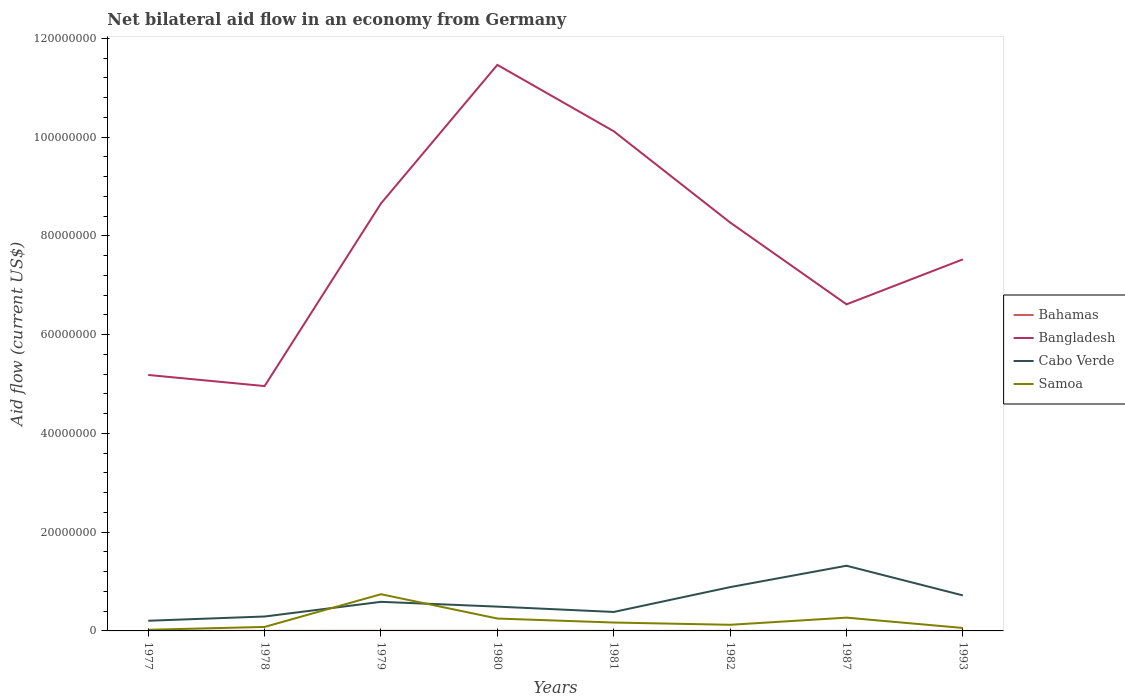Does the line corresponding to Bangladesh intersect with the line corresponding to Cabo Verde?
Your response must be concise. No. Is the number of lines equal to the number of legend labels?
Offer a terse response. Yes. In which year was the net bilateral aid flow in Cabo Verde maximum?
Make the answer very short. 1977. What is the total net bilateral aid flow in Bahamas in the graph?
Give a very brief answer. 10000. What is the difference between the highest and the second highest net bilateral aid flow in Cabo Verde?
Your answer should be compact. 1.11e+07. How many lines are there?
Ensure brevity in your answer.  4. Are the values on the major ticks of Y-axis written in scientific E-notation?
Your answer should be compact. No. Does the graph contain grids?
Your answer should be compact. No. What is the title of the graph?
Offer a terse response. Net bilateral aid flow in an economy from Germany. Does "Panama" appear as one of the legend labels in the graph?
Offer a very short reply. No. What is the Aid flow (current US$) of Bangladesh in 1977?
Keep it short and to the point. 5.18e+07. What is the Aid flow (current US$) of Cabo Verde in 1977?
Make the answer very short. 2.06e+06. What is the Aid flow (current US$) of Bahamas in 1978?
Ensure brevity in your answer.  10000. What is the Aid flow (current US$) of Bangladesh in 1978?
Your response must be concise. 4.96e+07. What is the Aid flow (current US$) of Cabo Verde in 1978?
Keep it short and to the point. 2.92e+06. What is the Aid flow (current US$) of Samoa in 1978?
Provide a short and direct response. 8.10e+05. What is the Aid flow (current US$) of Bangladesh in 1979?
Provide a short and direct response. 8.66e+07. What is the Aid flow (current US$) in Cabo Verde in 1979?
Offer a terse response. 5.89e+06. What is the Aid flow (current US$) in Samoa in 1979?
Offer a terse response. 7.43e+06. What is the Aid flow (current US$) of Bahamas in 1980?
Provide a short and direct response. 2.00e+04. What is the Aid flow (current US$) in Bangladesh in 1980?
Make the answer very short. 1.15e+08. What is the Aid flow (current US$) of Cabo Verde in 1980?
Provide a short and direct response. 4.92e+06. What is the Aid flow (current US$) in Samoa in 1980?
Offer a terse response. 2.51e+06. What is the Aid flow (current US$) of Bahamas in 1981?
Make the answer very short. 10000. What is the Aid flow (current US$) of Bangladesh in 1981?
Ensure brevity in your answer.  1.01e+08. What is the Aid flow (current US$) of Cabo Verde in 1981?
Keep it short and to the point. 3.84e+06. What is the Aid flow (current US$) of Samoa in 1981?
Your answer should be compact. 1.70e+06. What is the Aid flow (current US$) of Bangladesh in 1982?
Provide a short and direct response. 8.27e+07. What is the Aid flow (current US$) in Cabo Verde in 1982?
Offer a very short reply. 8.87e+06. What is the Aid flow (current US$) of Samoa in 1982?
Provide a succinct answer. 1.24e+06. What is the Aid flow (current US$) of Bahamas in 1987?
Your answer should be compact. 10000. What is the Aid flow (current US$) in Bangladesh in 1987?
Ensure brevity in your answer.  6.61e+07. What is the Aid flow (current US$) of Cabo Verde in 1987?
Your answer should be very brief. 1.32e+07. What is the Aid flow (current US$) in Samoa in 1987?
Ensure brevity in your answer.  2.69e+06. What is the Aid flow (current US$) in Bangladesh in 1993?
Make the answer very short. 7.52e+07. What is the Aid flow (current US$) in Cabo Verde in 1993?
Keep it short and to the point. 7.19e+06. Across all years, what is the maximum Aid flow (current US$) in Bahamas?
Your answer should be very brief. 2.00e+04. Across all years, what is the maximum Aid flow (current US$) in Bangladesh?
Give a very brief answer. 1.15e+08. Across all years, what is the maximum Aid flow (current US$) in Cabo Verde?
Offer a very short reply. 1.32e+07. Across all years, what is the maximum Aid flow (current US$) in Samoa?
Your response must be concise. 7.43e+06. Across all years, what is the minimum Aid flow (current US$) in Bangladesh?
Your answer should be very brief. 4.96e+07. Across all years, what is the minimum Aid flow (current US$) in Cabo Verde?
Provide a succinct answer. 2.06e+06. Across all years, what is the minimum Aid flow (current US$) of Samoa?
Offer a very short reply. 2.30e+05. What is the total Aid flow (current US$) of Bahamas in the graph?
Ensure brevity in your answer.  1.10e+05. What is the total Aid flow (current US$) of Bangladesh in the graph?
Keep it short and to the point. 6.28e+08. What is the total Aid flow (current US$) in Cabo Verde in the graph?
Make the answer very short. 4.89e+07. What is the total Aid flow (current US$) in Samoa in the graph?
Provide a succinct answer. 1.72e+07. What is the difference between the Aid flow (current US$) of Bangladesh in 1977 and that in 1978?
Your answer should be very brief. 2.25e+06. What is the difference between the Aid flow (current US$) of Cabo Verde in 1977 and that in 1978?
Your response must be concise. -8.60e+05. What is the difference between the Aid flow (current US$) of Samoa in 1977 and that in 1978?
Your answer should be compact. -5.80e+05. What is the difference between the Aid flow (current US$) of Bahamas in 1977 and that in 1979?
Make the answer very short. 0. What is the difference between the Aid flow (current US$) in Bangladesh in 1977 and that in 1979?
Offer a terse response. -3.47e+07. What is the difference between the Aid flow (current US$) of Cabo Verde in 1977 and that in 1979?
Offer a very short reply. -3.83e+06. What is the difference between the Aid flow (current US$) in Samoa in 1977 and that in 1979?
Give a very brief answer. -7.20e+06. What is the difference between the Aid flow (current US$) in Bangladesh in 1977 and that in 1980?
Ensure brevity in your answer.  -6.28e+07. What is the difference between the Aid flow (current US$) of Cabo Verde in 1977 and that in 1980?
Your answer should be very brief. -2.86e+06. What is the difference between the Aid flow (current US$) in Samoa in 1977 and that in 1980?
Ensure brevity in your answer.  -2.28e+06. What is the difference between the Aid flow (current US$) of Bahamas in 1977 and that in 1981?
Keep it short and to the point. 10000. What is the difference between the Aid flow (current US$) in Bangladesh in 1977 and that in 1981?
Your response must be concise. -4.94e+07. What is the difference between the Aid flow (current US$) of Cabo Verde in 1977 and that in 1981?
Keep it short and to the point. -1.78e+06. What is the difference between the Aid flow (current US$) in Samoa in 1977 and that in 1981?
Provide a succinct answer. -1.47e+06. What is the difference between the Aid flow (current US$) of Bangladesh in 1977 and that in 1982?
Provide a short and direct response. -3.09e+07. What is the difference between the Aid flow (current US$) in Cabo Verde in 1977 and that in 1982?
Make the answer very short. -6.81e+06. What is the difference between the Aid flow (current US$) of Samoa in 1977 and that in 1982?
Your answer should be very brief. -1.01e+06. What is the difference between the Aid flow (current US$) of Bangladesh in 1977 and that in 1987?
Ensure brevity in your answer.  -1.43e+07. What is the difference between the Aid flow (current US$) of Cabo Verde in 1977 and that in 1987?
Offer a terse response. -1.11e+07. What is the difference between the Aid flow (current US$) of Samoa in 1977 and that in 1987?
Give a very brief answer. -2.46e+06. What is the difference between the Aid flow (current US$) of Bahamas in 1977 and that in 1993?
Provide a short and direct response. 10000. What is the difference between the Aid flow (current US$) of Bangladesh in 1977 and that in 1993?
Your answer should be very brief. -2.34e+07. What is the difference between the Aid flow (current US$) in Cabo Verde in 1977 and that in 1993?
Give a very brief answer. -5.13e+06. What is the difference between the Aid flow (current US$) of Samoa in 1977 and that in 1993?
Make the answer very short. -3.70e+05. What is the difference between the Aid flow (current US$) of Bangladesh in 1978 and that in 1979?
Keep it short and to the point. -3.70e+07. What is the difference between the Aid flow (current US$) of Cabo Verde in 1978 and that in 1979?
Give a very brief answer. -2.97e+06. What is the difference between the Aid flow (current US$) of Samoa in 1978 and that in 1979?
Your response must be concise. -6.62e+06. What is the difference between the Aid flow (current US$) of Bahamas in 1978 and that in 1980?
Offer a very short reply. -10000. What is the difference between the Aid flow (current US$) in Bangladesh in 1978 and that in 1980?
Your response must be concise. -6.50e+07. What is the difference between the Aid flow (current US$) of Cabo Verde in 1978 and that in 1980?
Provide a short and direct response. -2.00e+06. What is the difference between the Aid flow (current US$) in Samoa in 1978 and that in 1980?
Provide a succinct answer. -1.70e+06. What is the difference between the Aid flow (current US$) of Bahamas in 1978 and that in 1981?
Keep it short and to the point. 0. What is the difference between the Aid flow (current US$) in Bangladesh in 1978 and that in 1981?
Give a very brief answer. -5.16e+07. What is the difference between the Aid flow (current US$) of Cabo Verde in 1978 and that in 1981?
Ensure brevity in your answer.  -9.20e+05. What is the difference between the Aid flow (current US$) in Samoa in 1978 and that in 1981?
Offer a terse response. -8.90e+05. What is the difference between the Aid flow (current US$) in Bangladesh in 1978 and that in 1982?
Give a very brief answer. -3.31e+07. What is the difference between the Aid flow (current US$) of Cabo Verde in 1978 and that in 1982?
Provide a short and direct response. -5.95e+06. What is the difference between the Aid flow (current US$) in Samoa in 1978 and that in 1982?
Give a very brief answer. -4.30e+05. What is the difference between the Aid flow (current US$) in Bangladesh in 1978 and that in 1987?
Give a very brief answer. -1.66e+07. What is the difference between the Aid flow (current US$) in Cabo Verde in 1978 and that in 1987?
Offer a very short reply. -1.03e+07. What is the difference between the Aid flow (current US$) in Samoa in 1978 and that in 1987?
Give a very brief answer. -1.88e+06. What is the difference between the Aid flow (current US$) in Bahamas in 1978 and that in 1993?
Ensure brevity in your answer.  0. What is the difference between the Aid flow (current US$) in Bangladesh in 1978 and that in 1993?
Offer a terse response. -2.57e+07. What is the difference between the Aid flow (current US$) in Cabo Verde in 1978 and that in 1993?
Give a very brief answer. -4.27e+06. What is the difference between the Aid flow (current US$) of Bangladesh in 1979 and that in 1980?
Give a very brief answer. -2.81e+07. What is the difference between the Aid flow (current US$) in Cabo Verde in 1979 and that in 1980?
Your answer should be compact. 9.70e+05. What is the difference between the Aid flow (current US$) of Samoa in 1979 and that in 1980?
Keep it short and to the point. 4.92e+06. What is the difference between the Aid flow (current US$) in Bahamas in 1979 and that in 1981?
Give a very brief answer. 10000. What is the difference between the Aid flow (current US$) in Bangladesh in 1979 and that in 1981?
Your answer should be very brief. -1.46e+07. What is the difference between the Aid flow (current US$) of Cabo Verde in 1979 and that in 1981?
Your answer should be compact. 2.05e+06. What is the difference between the Aid flow (current US$) in Samoa in 1979 and that in 1981?
Your response must be concise. 5.73e+06. What is the difference between the Aid flow (current US$) of Bangladesh in 1979 and that in 1982?
Make the answer very short. 3.85e+06. What is the difference between the Aid flow (current US$) of Cabo Verde in 1979 and that in 1982?
Your response must be concise. -2.98e+06. What is the difference between the Aid flow (current US$) of Samoa in 1979 and that in 1982?
Give a very brief answer. 6.19e+06. What is the difference between the Aid flow (current US$) in Bangladesh in 1979 and that in 1987?
Your answer should be compact. 2.04e+07. What is the difference between the Aid flow (current US$) of Cabo Verde in 1979 and that in 1987?
Offer a terse response. -7.31e+06. What is the difference between the Aid flow (current US$) in Samoa in 1979 and that in 1987?
Your answer should be very brief. 4.74e+06. What is the difference between the Aid flow (current US$) in Bahamas in 1979 and that in 1993?
Offer a terse response. 10000. What is the difference between the Aid flow (current US$) in Bangladesh in 1979 and that in 1993?
Make the answer very short. 1.13e+07. What is the difference between the Aid flow (current US$) of Cabo Verde in 1979 and that in 1993?
Your answer should be compact. -1.30e+06. What is the difference between the Aid flow (current US$) of Samoa in 1979 and that in 1993?
Give a very brief answer. 6.83e+06. What is the difference between the Aid flow (current US$) in Bahamas in 1980 and that in 1981?
Give a very brief answer. 10000. What is the difference between the Aid flow (current US$) of Bangladesh in 1980 and that in 1981?
Make the answer very short. 1.34e+07. What is the difference between the Aid flow (current US$) of Cabo Verde in 1980 and that in 1981?
Offer a very short reply. 1.08e+06. What is the difference between the Aid flow (current US$) of Samoa in 1980 and that in 1981?
Give a very brief answer. 8.10e+05. What is the difference between the Aid flow (current US$) of Bahamas in 1980 and that in 1982?
Make the answer very short. 10000. What is the difference between the Aid flow (current US$) in Bangladesh in 1980 and that in 1982?
Give a very brief answer. 3.19e+07. What is the difference between the Aid flow (current US$) in Cabo Verde in 1980 and that in 1982?
Give a very brief answer. -3.95e+06. What is the difference between the Aid flow (current US$) of Samoa in 1980 and that in 1982?
Ensure brevity in your answer.  1.27e+06. What is the difference between the Aid flow (current US$) of Bahamas in 1980 and that in 1987?
Provide a succinct answer. 10000. What is the difference between the Aid flow (current US$) in Bangladesh in 1980 and that in 1987?
Provide a succinct answer. 4.85e+07. What is the difference between the Aid flow (current US$) in Cabo Verde in 1980 and that in 1987?
Make the answer very short. -8.28e+06. What is the difference between the Aid flow (current US$) of Samoa in 1980 and that in 1987?
Keep it short and to the point. -1.80e+05. What is the difference between the Aid flow (current US$) in Bangladesh in 1980 and that in 1993?
Your answer should be very brief. 3.94e+07. What is the difference between the Aid flow (current US$) of Cabo Verde in 1980 and that in 1993?
Ensure brevity in your answer.  -2.27e+06. What is the difference between the Aid flow (current US$) of Samoa in 1980 and that in 1993?
Offer a very short reply. 1.91e+06. What is the difference between the Aid flow (current US$) in Bahamas in 1981 and that in 1982?
Ensure brevity in your answer.  0. What is the difference between the Aid flow (current US$) in Bangladesh in 1981 and that in 1982?
Give a very brief answer. 1.85e+07. What is the difference between the Aid flow (current US$) of Cabo Verde in 1981 and that in 1982?
Your response must be concise. -5.03e+06. What is the difference between the Aid flow (current US$) in Samoa in 1981 and that in 1982?
Provide a succinct answer. 4.60e+05. What is the difference between the Aid flow (current US$) of Bangladesh in 1981 and that in 1987?
Offer a very short reply. 3.50e+07. What is the difference between the Aid flow (current US$) in Cabo Verde in 1981 and that in 1987?
Make the answer very short. -9.36e+06. What is the difference between the Aid flow (current US$) of Samoa in 1981 and that in 1987?
Keep it short and to the point. -9.90e+05. What is the difference between the Aid flow (current US$) of Bahamas in 1981 and that in 1993?
Keep it short and to the point. 0. What is the difference between the Aid flow (current US$) of Bangladesh in 1981 and that in 1993?
Offer a terse response. 2.59e+07. What is the difference between the Aid flow (current US$) in Cabo Verde in 1981 and that in 1993?
Offer a very short reply. -3.35e+06. What is the difference between the Aid flow (current US$) in Samoa in 1981 and that in 1993?
Offer a terse response. 1.10e+06. What is the difference between the Aid flow (current US$) in Bahamas in 1982 and that in 1987?
Keep it short and to the point. 0. What is the difference between the Aid flow (current US$) of Bangladesh in 1982 and that in 1987?
Offer a terse response. 1.66e+07. What is the difference between the Aid flow (current US$) in Cabo Verde in 1982 and that in 1987?
Make the answer very short. -4.33e+06. What is the difference between the Aid flow (current US$) in Samoa in 1982 and that in 1987?
Give a very brief answer. -1.45e+06. What is the difference between the Aid flow (current US$) of Bangladesh in 1982 and that in 1993?
Provide a succinct answer. 7.47e+06. What is the difference between the Aid flow (current US$) in Cabo Verde in 1982 and that in 1993?
Offer a terse response. 1.68e+06. What is the difference between the Aid flow (current US$) of Samoa in 1982 and that in 1993?
Offer a terse response. 6.40e+05. What is the difference between the Aid flow (current US$) of Bangladesh in 1987 and that in 1993?
Your answer should be very brief. -9.11e+06. What is the difference between the Aid flow (current US$) in Cabo Verde in 1987 and that in 1993?
Provide a succinct answer. 6.01e+06. What is the difference between the Aid flow (current US$) of Samoa in 1987 and that in 1993?
Your answer should be compact. 2.09e+06. What is the difference between the Aid flow (current US$) of Bahamas in 1977 and the Aid flow (current US$) of Bangladesh in 1978?
Keep it short and to the point. -4.96e+07. What is the difference between the Aid flow (current US$) of Bahamas in 1977 and the Aid flow (current US$) of Cabo Verde in 1978?
Make the answer very short. -2.90e+06. What is the difference between the Aid flow (current US$) in Bahamas in 1977 and the Aid flow (current US$) in Samoa in 1978?
Provide a succinct answer. -7.90e+05. What is the difference between the Aid flow (current US$) of Bangladesh in 1977 and the Aid flow (current US$) of Cabo Verde in 1978?
Your answer should be very brief. 4.89e+07. What is the difference between the Aid flow (current US$) in Bangladesh in 1977 and the Aid flow (current US$) in Samoa in 1978?
Provide a short and direct response. 5.10e+07. What is the difference between the Aid flow (current US$) in Cabo Verde in 1977 and the Aid flow (current US$) in Samoa in 1978?
Keep it short and to the point. 1.25e+06. What is the difference between the Aid flow (current US$) in Bahamas in 1977 and the Aid flow (current US$) in Bangladesh in 1979?
Provide a short and direct response. -8.65e+07. What is the difference between the Aid flow (current US$) in Bahamas in 1977 and the Aid flow (current US$) in Cabo Verde in 1979?
Make the answer very short. -5.87e+06. What is the difference between the Aid flow (current US$) of Bahamas in 1977 and the Aid flow (current US$) of Samoa in 1979?
Offer a terse response. -7.41e+06. What is the difference between the Aid flow (current US$) in Bangladesh in 1977 and the Aid flow (current US$) in Cabo Verde in 1979?
Provide a short and direct response. 4.59e+07. What is the difference between the Aid flow (current US$) in Bangladesh in 1977 and the Aid flow (current US$) in Samoa in 1979?
Keep it short and to the point. 4.44e+07. What is the difference between the Aid flow (current US$) of Cabo Verde in 1977 and the Aid flow (current US$) of Samoa in 1979?
Ensure brevity in your answer.  -5.37e+06. What is the difference between the Aid flow (current US$) in Bahamas in 1977 and the Aid flow (current US$) in Bangladesh in 1980?
Your response must be concise. -1.15e+08. What is the difference between the Aid flow (current US$) of Bahamas in 1977 and the Aid flow (current US$) of Cabo Verde in 1980?
Offer a terse response. -4.90e+06. What is the difference between the Aid flow (current US$) in Bahamas in 1977 and the Aid flow (current US$) in Samoa in 1980?
Your response must be concise. -2.49e+06. What is the difference between the Aid flow (current US$) of Bangladesh in 1977 and the Aid flow (current US$) of Cabo Verde in 1980?
Your answer should be very brief. 4.69e+07. What is the difference between the Aid flow (current US$) of Bangladesh in 1977 and the Aid flow (current US$) of Samoa in 1980?
Keep it short and to the point. 4.93e+07. What is the difference between the Aid flow (current US$) in Cabo Verde in 1977 and the Aid flow (current US$) in Samoa in 1980?
Provide a short and direct response. -4.50e+05. What is the difference between the Aid flow (current US$) in Bahamas in 1977 and the Aid flow (current US$) in Bangladesh in 1981?
Keep it short and to the point. -1.01e+08. What is the difference between the Aid flow (current US$) of Bahamas in 1977 and the Aid flow (current US$) of Cabo Verde in 1981?
Your answer should be very brief. -3.82e+06. What is the difference between the Aid flow (current US$) in Bahamas in 1977 and the Aid flow (current US$) in Samoa in 1981?
Offer a very short reply. -1.68e+06. What is the difference between the Aid flow (current US$) in Bangladesh in 1977 and the Aid flow (current US$) in Cabo Verde in 1981?
Ensure brevity in your answer.  4.80e+07. What is the difference between the Aid flow (current US$) of Bangladesh in 1977 and the Aid flow (current US$) of Samoa in 1981?
Your answer should be compact. 5.01e+07. What is the difference between the Aid flow (current US$) of Cabo Verde in 1977 and the Aid flow (current US$) of Samoa in 1981?
Keep it short and to the point. 3.60e+05. What is the difference between the Aid flow (current US$) in Bahamas in 1977 and the Aid flow (current US$) in Bangladesh in 1982?
Provide a succinct answer. -8.27e+07. What is the difference between the Aid flow (current US$) of Bahamas in 1977 and the Aid flow (current US$) of Cabo Verde in 1982?
Make the answer very short. -8.85e+06. What is the difference between the Aid flow (current US$) of Bahamas in 1977 and the Aid flow (current US$) of Samoa in 1982?
Give a very brief answer. -1.22e+06. What is the difference between the Aid flow (current US$) in Bangladesh in 1977 and the Aid flow (current US$) in Cabo Verde in 1982?
Make the answer very short. 4.30e+07. What is the difference between the Aid flow (current US$) of Bangladesh in 1977 and the Aid flow (current US$) of Samoa in 1982?
Give a very brief answer. 5.06e+07. What is the difference between the Aid flow (current US$) in Cabo Verde in 1977 and the Aid flow (current US$) in Samoa in 1982?
Make the answer very short. 8.20e+05. What is the difference between the Aid flow (current US$) of Bahamas in 1977 and the Aid flow (current US$) of Bangladesh in 1987?
Offer a terse response. -6.61e+07. What is the difference between the Aid flow (current US$) in Bahamas in 1977 and the Aid flow (current US$) in Cabo Verde in 1987?
Offer a very short reply. -1.32e+07. What is the difference between the Aid flow (current US$) in Bahamas in 1977 and the Aid flow (current US$) in Samoa in 1987?
Provide a short and direct response. -2.67e+06. What is the difference between the Aid flow (current US$) of Bangladesh in 1977 and the Aid flow (current US$) of Cabo Verde in 1987?
Ensure brevity in your answer.  3.86e+07. What is the difference between the Aid flow (current US$) in Bangladesh in 1977 and the Aid flow (current US$) in Samoa in 1987?
Give a very brief answer. 4.91e+07. What is the difference between the Aid flow (current US$) in Cabo Verde in 1977 and the Aid flow (current US$) in Samoa in 1987?
Keep it short and to the point. -6.30e+05. What is the difference between the Aid flow (current US$) in Bahamas in 1977 and the Aid flow (current US$) in Bangladesh in 1993?
Offer a terse response. -7.52e+07. What is the difference between the Aid flow (current US$) in Bahamas in 1977 and the Aid flow (current US$) in Cabo Verde in 1993?
Offer a terse response. -7.17e+06. What is the difference between the Aid flow (current US$) of Bahamas in 1977 and the Aid flow (current US$) of Samoa in 1993?
Offer a terse response. -5.80e+05. What is the difference between the Aid flow (current US$) of Bangladesh in 1977 and the Aid flow (current US$) of Cabo Verde in 1993?
Offer a terse response. 4.46e+07. What is the difference between the Aid flow (current US$) in Bangladesh in 1977 and the Aid flow (current US$) in Samoa in 1993?
Keep it short and to the point. 5.12e+07. What is the difference between the Aid flow (current US$) of Cabo Verde in 1977 and the Aid flow (current US$) of Samoa in 1993?
Your answer should be very brief. 1.46e+06. What is the difference between the Aid flow (current US$) of Bahamas in 1978 and the Aid flow (current US$) of Bangladesh in 1979?
Give a very brief answer. -8.66e+07. What is the difference between the Aid flow (current US$) in Bahamas in 1978 and the Aid flow (current US$) in Cabo Verde in 1979?
Provide a succinct answer. -5.88e+06. What is the difference between the Aid flow (current US$) of Bahamas in 1978 and the Aid flow (current US$) of Samoa in 1979?
Make the answer very short. -7.42e+06. What is the difference between the Aid flow (current US$) in Bangladesh in 1978 and the Aid flow (current US$) in Cabo Verde in 1979?
Provide a short and direct response. 4.37e+07. What is the difference between the Aid flow (current US$) of Bangladesh in 1978 and the Aid flow (current US$) of Samoa in 1979?
Offer a very short reply. 4.22e+07. What is the difference between the Aid flow (current US$) in Cabo Verde in 1978 and the Aid flow (current US$) in Samoa in 1979?
Provide a short and direct response. -4.51e+06. What is the difference between the Aid flow (current US$) of Bahamas in 1978 and the Aid flow (current US$) of Bangladesh in 1980?
Offer a terse response. -1.15e+08. What is the difference between the Aid flow (current US$) in Bahamas in 1978 and the Aid flow (current US$) in Cabo Verde in 1980?
Offer a very short reply. -4.91e+06. What is the difference between the Aid flow (current US$) in Bahamas in 1978 and the Aid flow (current US$) in Samoa in 1980?
Provide a short and direct response. -2.50e+06. What is the difference between the Aid flow (current US$) in Bangladesh in 1978 and the Aid flow (current US$) in Cabo Verde in 1980?
Keep it short and to the point. 4.47e+07. What is the difference between the Aid flow (current US$) of Bangladesh in 1978 and the Aid flow (current US$) of Samoa in 1980?
Your response must be concise. 4.71e+07. What is the difference between the Aid flow (current US$) of Bahamas in 1978 and the Aid flow (current US$) of Bangladesh in 1981?
Your answer should be very brief. -1.01e+08. What is the difference between the Aid flow (current US$) in Bahamas in 1978 and the Aid flow (current US$) in Cabo Verde in 1981?
Your answer should be compact. -3.83e+06. What is the difference between the Aid flow (current US$) in Bahamas in 1978 and the Aid flow (current US$) in Samoa in 1981?
Provide a succinct answer. -1.69e+06. What is the difference between the Aid flow (current US$) in Bangladesh in 1978 and the Aid flow (current US$) in Cabo Verde in 1981?
Keep it short and to the point. 4.57e+07. What is the difference between the Aid flow (current US$) of Bangladesh in 1978 and the Aid flow (current US$) of Samoa in 1981?
Keep it short and to the point. 4.79e+07. What is the difference between the Aid flow (current US$) of Cabo Verde in 1978 and the Aid flow (current US$) of Samoa in 1981?
Provide a short and direct response. 1.22e+06. What is the difference between the Aid flow (current US$) of Bahamas in 1978 and the Aid flow (current US$) of Bangladesh in 1982?
Offer a terse response. -8.27e+07. What is the difference between the Aid flow (current US$) in Bahamas in 1978 and the Aid flow (current US$) in Cabo Verde in 1982?
Keep it short and to the point. -8.86e+06. What is the difference between the Aid flow (current US$) in Bahamas in 1978 and the Aid flow (current US$) in Samoa in 1982?
Your response must be concise. -1.23e+06. What is the difference between the Aid flow (current US$) in Bangladesh in 1978 and the Aid flow (current US$) in Cabo Verde in 1982?
Ensure brevity in your answer.  4.07e+07. What is the difference between the Aid flow (current US$) of Bangladesh in 1978 and the Aid flow (current US$) of Samoa in 1982?
Keep it short and to the point. 4.83e+07. What is the difference between the Aid flow (current US$) in Cabo Verde in 1978 and the Aid flow (current US$) in Samoa in 1982?
Provide a succinct answer. 1.68e+06. What is the difference between the Aid flow (current US$) of Bahamas in 1978 and the Aid flow (current US$) of Bangladesh in 1987?
Offer a terse response. -6.61e+07. What is the difference between the Aid flow (current US$) of Bahamas in 1978 and the Aid flow (current US$) of Cabo Verde in 1987?
Ensure brevity in your answer.  -1.32e+07. What is the difference between the Aid flow (current US$) of Bahamas in 1978 and the Aid flow (current US$) of Samoa in 1987?
Offer a very short reply. -2.68e+06. What is the difference between the Aid flow (current US$) of Bangladesh in 1978 and the Aid flow (current US$) of Cabo Verde in 1987?
Offer a very short reply. 3.64e+07. What is the difference between the Aid flow (current US$) of Bangladesh in 1978 and the Aid flow (current US$) of Samoa in 1987?
Your response must be concise. 4.69e+07. What is the difference between the Aid flow (current US$) of Bahamas in 1978 and the Aid flow (current US$) of Bangladesh in 1993?
Your answer should be very brief. -7.52e+07. What is the difference between the Aid flow (current US$) in Bahamas in 1978 and the Aid flow (current US$) in Cabo Verde in 1993?
Your answer should be compact. -7.18e+06. What is the difference between the Aid flow (current US$) in Bahamas in 1978 and the Aid flow (current US$) in Samoa in 1993?
Your answer should be compact. -5.90e+05. What is the difference between the Aid flow (current US$) of Bangladesh in 1978 and the Aid flow (current US$) of Cabo Verde in 1993?
Your answer should be very brief. 4.24e+07. What is the difference between the Aid flow (current US$) in Bangladesh in 1978 and the Aid flow (current US$) in Samoa in 1993?
Make the answer very short. 4.90e+07. What is the difference between the Aid flow (current US$) of Cabo Verde in 1978 and the Aid flow (current US$) of Samoa in 1993?
Your answer should be compact. 2.32e+06. What is the difference between the Aid flow (current US$) of Bahamas in 1979 and the Aid flow (current US$) of Bangladesh in 1980?
Your answer should be very brief. -1.15e+08. What is the difference between the Aid flow (current US$) of Bahamas in 1979 and the Aid flow (current US$) of Cabo Verde in 1980?
Your answer should be very brief. -4.90e+06. What is the difference between the Aid flow (current US$) in Bahamas in 1979 and the Aid flow (current US$) in Samoa in 1980?
Offer a very short reply. -2.49e+06. What is the difference between the Aid flow (current US$) of Bangladesh in 1979 and the Aid flow (current US$) of Cabo Verde in 1980?
Make the answer very short. 8.16e+07. What is the difference between the Aid flow (current US$) in Bangladesh in 1979 and the Aid flow (current US$) in Samoa in 1980?
Your response must be concise. 8.40e+07. What is the difference between the Aid flow (current US$) in Cabo Verde in 1979 and the Aid flow (current US$) in Samoa in 1980?
Your response must be concise. 3.38e+06. What is the difference between the Aid flow (current US$) of Bahamas in 1979 and the Aid flow (current US$) of Bangladesh in 1981?
Make the answer very short. -1.01e+08. What is the difference between the Aid flow (current US$) of Bahamas in 1979 and the Aid flow (current US$) of Cabo Verde in 1981?
Your response must be concise. -3.82e+06. What is the difference between the Aid flow (current US$) of Bahamas in 1979 and the Aid flow (current US$) of Samoa in 1981?
Offer a terse response. -1.68e+06. What is the difference between the Aid flow (current US$) of Bangladesh in 1979 and the Aid flow (current US$) of Cabo Verde in 1981?
Make the answer very short. 8.27e+07. What is the difference between the Aid flow (current US$) in Bangladesh in 1979 and the Aid flow (current US$) in Samoa in 1981?
Keep it short and to the point. 8.49e+07. What is the difference between the Aid flow (current US$) of Cabo Verde in 1979 and the Aid flow (current US$) of Samoa in 1981?
Offer a very short reply. 4.19e+06. What is the difference between the Aid flow (current US$) of Bahamas in 1979 and the Aid flow (current US$) of Bangladesh in 1982?
Keep it short and to the point. -8.27e+07. What is the difference between the Aid flow (current US$) of Bahamas in 1979 and the Aid flow (current US$) of Cabo Verde in 1982?
Make the answer very short. -8.85e+06. What is the difference between the Aid flow (current US$) of Bahamas in 1979 and the Aid flow (current US$) of Samoa in 1982?
Give a very brief answer. -1.22e+06. What is the difference between the Aid flow (current US$) of Bangladesh in 1979 and the Aid flow (current US$) of Cabo Verde in 1982?
Offer a very short reply. 7.77e+07. What is the difference between the Aid flow (current US$) in Bangladesh in 1979 and the Aid flow (current US$) in Samoa in 1982?
Give a very brief answer. 8.53e+07. What is the difference between the Aid flow (current US$) of Cabo Verde in 1979 and the Aid flow (current US$) of Samoa in 1982?
Your response must be concise. 4.65e+06. What is the difference between the Aid flow (current US$) in Bahamas in 1979 and the Aid flow (current US$) in Bangladesh in 1987?
Give a very brief answer. -6.61e+07. What is the difference between the Aid flow (current US$) in Bahamas in 1979 and the Aid flow (current US$) in Cabo Verde in 1987?
Offer a terse response. -1.32e+07. What is the difference between the Aid flow (current US$) of Bahamas in 1979 and the Aid flow (current US$) of Samoa in 1987?
Make the answer very short. -2.67e+06. What is the difference between the Aid flow (current US$) in Bangladesh in 1979 and the Aid flow (current US$) in Cabo Verde in 1987?
Offer a very short reply. 7.34e+07. What is the difference between the Aid flow (current US$) of Bangladesh in 1979 and the Aid flow (current US$) of Samoa in 1987?
Offer a terse response. 8.39e+07. What is the difference between the Aid flow (current US$) in Cabo Verde in 1979 and the Aid flow (current US$) in Samoa in 1987?
Offer a terse response. 3.20e+06. What is the difference between the Aid flow (current US$) of Bahamas in 1979 and the Aid flow (current US$) of Bangladesh in 1993?
Make the answer very short. -7.52e+07. What is the difference between the Aid flow (current US$) in Bahamas in 1979 and the Aid flow (current US$) in Cabo Verde in 1993?
Provide a succinct answer. -7.17e+06. What is the difference between the Aid flow (current US$) in Bahamas in 1979 and the Aid flow (current US$) in Samoa in 1993?
Offer a very short reply. -5.80e+05. What is the difference between the Aid flow (current US$) of Bangladesh in 1979 and the Aid flow (current US$) of Cabo Verde in 1993?
Ensure brevity in your answer.  7.94e+07. What is the difference between the Aid flow (current US$) of Bangladesh in 1979 and the Aid flow (current US$) of Samoa in 1993?
Make the answer very short. 8.60e+07. What is the difference between the Aid flow (current US$) of Cabo Verde in 1979 and the Aid flow (current US$) of Samoa in 1993?
Provide a short and direct response. 5.29e+06. What is the difference between the Aid flow (current US$) in Bahamas in 1980 and the Aid flow (current US$) in Bangladesh in 1981?
Provide a short and direct response. -1.01e+08. What is the difference between the Aid flow (current US$) in Bahamas in 1980 and the Aid flow (current US$) in Cabo Verde in 1981?
Make the answer very short. -3.82e+06. What is the difference between the Aid flow (current US$) of Bahamas in 1980 and the Aid flow (current US$) of Samoa in 1981?
Give a very brief answer. -1.68e+06. What is the difference between the Aid flow (current US$) in Bangladesh in 1980 and the Aid flow (current US$) in Cabo Verde in 1981?
Make the answer very short. 1.11e+08. What is the difference between the Aid flow (current US$) of Bangladesh in 1980 and the Aid flow (current US$) of Samoa in 1981?
Make the answer very short. 1.13e+08. What is the difference between the Aid flow (current US$) in Cabo Verde in 1980 and the Aid flow (current US$) in Samoa in 1981?
Provide a short and direct response. 3.22e+06. What is the difference between the Aid flow (current US$) of Bahamas in 1980 and the Aid flow (current US$) of Bangladesh in 1982?
Offer a terse response. -8.27e+07. What is the difference between the Aid flow (current US$) in Bahamas in 1980 and the Aid flow (current US$) in Cabo Verde in 1982?
Ensure brevity in your answer.  -8.85e+06. What is the difference between the Aid flow (current US$) of Bahamas in 1980 and the Aid flow (current US$) of Samoa in 1982?
Ensure brevity in your answer.  -1.22e+06. What is the difference between the Aid flow (current US$) in Bangladesh in 1980 and the Aid flow (current US$) in Cabo Verde in 1982?
Keep it short and to the point. 1.06e+08. What is the difference between the Aid flow (current US$) of Bangladesh in 1980 and the Aid flow (current US$) of Samoa in 1982?
Keep it short and to the point. 1.13e+08. What is the difference between the Aid flow (current US$) of Cabo Verde in 1980 and the Aid flow (current US$) of Samoa in 1982?
Make the answer very short. 3.68e+06. What is the difference between the Aid flow (current US$) in Bahamas in 1980 and the Aid flow (current US$) in Bangladesh in 1987?
Keep it short and to the point. -6.61e+07. What is the difference between the Aid flow (current US$) of Bahamas in 1980 and the Aid flow (current US$) of Cabo Verde in 1987?
Offer a terse response. -1.32e+07. What is the difference between the Aid flow (current US$) of Bahamas in 1980 and the Aid flow (current US$) of Samoa in 1987?
Make the answer very short. -2.67e+06. What is the difference between the Aid flow (current US$) of Bangladesh in 1980 and the Aid flow (current US$) of Cabo Verde in 1987?
Provide a succinct answer. 1.01e+08. What is the difference between the Aid flow (current US$) in Bangladesh in 1980 and the Aid flow (current US$) in Samoa in 1987?
Offer a terse response. 1.12e+08. What is the difference between the Aid flow (current US$) of Cabo Verde in 1980 and the Aid flow (current US$) of Samoa in 1987?
Your response must be concise. 2.23e+06. What is the difference between the Aid flow (current US$) in Bahamas in 1980 and the Aid flow (current US$) in Bangladesh in 1993?
Keep it short and to the point. -7.52e+07. What is the difference between the Aid flow (current US$) in Bahamas in 1980 and the Aid flow (current US$) in Cabo Verde in 1993?
Your answer should be compact. -7.17e+06. What is the difference between the Aid flow (current US$) in Bahamas in 1980 and the Aid flow (current US$) in Samoa in 1993?
Your response must be concise. -5.80e+05. What is the difference between the Aid flow (current US$) of Bangladesh in 1980 and the Aid flow (current US$) of Cabo Verde in 1993?
Provide a short and direct response. 1.07e+08. What is the difference between the Aid flow (current US$) in Bangladesh in 1980 and the Aid flow (current US$) in Samoa in 1993?
Give a very brief answer. 1.14e+08. What is the difference between the Aid flow (current US$) of Cabo Verde in 1980 and the Aid flow (current US$) of Samoa in 1993?
Provide a short and direct response. 4.32e+06. What is the difference between the Aid flow (current US$) in Bahamas in 1981 and the Aid flow (current US$) in Bangladesh in 1982?
Make the answer very short. -8.27e+07. What is the difference between the Aid flow (current US$) of Bahamas in 1981 and the Aid flow (current US$) of Cabo Verde in 1982?
Make the answer very short. -8.86e+06. What is the difference between the Aid flow (current US$) in Bahamas in 1981 and the Aid flow (current US$) in Samoa in 1982?
Provide a succinct answer. -1.23e+06. What is the difference between the Aid flow (current US$) in Bangladesh in 1981 and the Aid flow (current US$) in Cabo Verde in 1982?
Your answer should be compact. 9.23e+07. What is the difference between the Aid flow (current US$) of Bangladesh in 1981 and the Aid flow (current US$) of Samoa in 1982?
Give a very brief answer. 9.99e+07. What is the difference between the Aid flow (current US$) of Cabo Verde in 1981 and the Aid flow (current US$) of Samoa in 1982?
Keep it short and to the point. 2.60e+06. What is the difference between the Aid flow (current US$) in Bahamas in 1981 and the Aid flow (current US$) in Bangladesh in 1987?
Keep it short and to the point. -6.61e+07. What is the difference between the Aid flow (current US$) of Bahamas in 1981 and the Aid flow (current US$) of Cabo Verde in 1987?
Your answer should be compact. -1.32e+07. What is the difference between the Aid flow (current US$) in Bahamas in 1981 and the Aid flow (current US$) in Samoa in 1987?
Your response must be concise. -2.68e+06. What is the difference between the Aid flow (current US$) in Bangladesh in 1981 and the Aid flow (current US$) in Cabo Verde in 1987?
Provide a short and direct response. 8.80e+07. What is the difference between the Aid flow (current US$) of Bangladesh in 1981 and the Aid flow (current US$) of Samoa in 1987?
Make the answer very short. 9.85e+07. What is the difference between the Aid flow (current US$) in Cabo Verde in 1981 and the Aid flow (current US$) in Samoa in 1987?
Offer a terse response. 1.15e+06. What is the difference between the Aid flow (current US$) of Bahamas in 1981 and the Aid flow (current US$) of Bangladesh in 1993?
Your answer should be very brief. -7.52e+07. What is the difference between the Aid flow (current US$) in Bahamas in 1981 and the Aid flow (current US$) in Cabo Verde in 1993?
Make the answer very short. -7.18e+06. What is the difference between the Aid flow (current US$) in Bahamas in 1981 and the Aid flow (current US$) in Samoa in 1993?
Offer a terse response. -5.90e+05. What is the difference between the Aid flow (current US$) of Bangladesh in 1981 and the Aid flow (current US$) of Cabo Verde in 1993?
Your answer should be very brief. 9.40e+07. What is the difference between the Aid flow (current US$) in Bangladesh in 1981 and the Aid flow (current US$) in Samoa in 1993?
Offer a terse response. 1.01e+08. What is the difference between the Aid flow (current US$) in Cabo Verde in 1981 and the Aid flow (current US$) in Samoa in 1993?
Offer a terse response. 3.24e+06. What is the difference between the Aid flow (current US$) of Bahamas in 1982 and the Aid flow (current US$) of Bangladesh in 1987?
Offer a terse response. -6.61e+07. What is the difference between the Aid flow (current US$) of Bahamas in 1982 and the Aid flow (current US$) of Cabo Verde in 1987?
Provide a short and direct response. -1.32e+07. What is the difference between the Aid flow (current US$) in Bahamas in 1982 and the Aid flow (current US$) in Samoa in 1987?
Your answer should be compact. -2.68e+06. What is the difference between the Aid flow (current US$) of Bangladesh in 1982 and the Aid flow (current US$) of Cabo Verde in 1987?
Give a very brief answer. 6.95e+07. What is the difference between the Aid flow (current US$) in Bangladesh in 1982 and the Aid flow (current US$) in Samoa in 1987?
Offer a terse response. 8.00e+07. What is the difference between the Aid flow (current US$) in Cabo Verde in 1982 and the Aid flow (current US$) in Samoa in 1987?
Give a very brief answer. 6.18e+06. What is the difference between the Aid flow (current US$) in Bahamas in 1982 and the Aid flow (current US$) in Bangladesh in 1993?
Make the answer very short. -7.52e+07. What is the difference between the Aid flow (current US$) of Bahamas in 1982 and the Aid flow (current US$) of Cabo Verde in 1993?
Keep it short and to the point. -7.18e+06. What is the difference between the Aid flow (current US$) in Bahamas in 1982 and the Aid flow (current US$) in Samoa in 1993?
Give a very brief answer. -5.90e+05. What is the difference between the Aid flow (current US$) of Bangladesh in 1982 and the Aid flow (current US$) of Cabo Verde in 1993?
Provide a short and direct response. 7.55e+07. What is the difference between the Aid flow (current US$) of Bangladesh in 1982 and the Aid flow (current US$) of Samoa in 1993?
Give a very brief answer. 8.21e+07. What is the difference between the Aid flow (current US$) of Cabo Verde in 1982 and the Aid flow (current US$) of Samoa in 1993?
Provide a succinct answer. 8.27e+06. What is the difference between the Aid flow (current US$) in Bahamas in 1987 and the Aid flow (current US$) in Bangladesh in 1993?
Ensure brevity in your answer.  -7.52e+07. What is the difference between the Aid flow (current US$) in Bahamas in 1987 and the Aid flow (current US$) in Cabo Verde in 1993?
Give a very brief answer. -7.18e+06. What is the difference between the Aid flow (current US$) in Bahamas in 1987 and the Aid flow (current US$) in Samoa in 1993?
Make the answer very short. -5.90e+05. What is the difference between the Aid flow (current US$) of Bangladesh in 1987 and the Aid flow (current US$) of Cabo Verde in 1993?
Keep it short and to the point. 5.89e+07. What is the difference between the Aid flow (current US$) in Bangladesh in 1987 and the Aid flow (current US$) in Samoa in 1993?
Keep it short and to the point. 6.55e+07. What is the difference between the Aid flow (current US$) in Cabo Verde in 1987 and the Aid flow (current US$) in Samoa in 1993?
Provide a succinct answer. 1.26e+07. What is the average Aid flow (current US$) of Bahamas per year?
Keep it short and to the point. 1.38e+04. What is the average Aid flow (current US$) of Bangladesh per year?
Keep it short and to the point. 7.85e+07. What is the average Aid flow (current US$) in Cabo Verde per year?
Keep it short and to the point. 6.11e+06. What is the average Aid flow (current US$) of Samoa per year?
Give a very brief answer. 2.15e+06. In the year 1977, what is the difference between the Aid flow (current US$) of Bahamas and Aid flow (current US$) of Bangladesh?
Keep it short and to the point. -5.18e+07. In the year 1977, what is the difference between the Aid flow (current US$) in Bahamas and Aid flow (current US$) in Cabo Verde?
Your answer should be very brief. -2.04e+06. In the year 1977, what is the difference between the Aid flow (current US$) of Bangladesh and Aid flow (current US$) of Cabo Verde?
Your answer should be compact. 4.98e+07. In the year 1977, what is the difference between the Aid flow (current US$) of Bangladesh and Aid flow (current US$) of Samoa?
Give a very brief answer. 5.16e+07. In the year 1977, what is the difference between the Aid flow (current US$) of Cabo Verde and Aid flow (current US$) of Samoa?
Your answer should be compact. 1.83e+06. In the year 1978, what is the difference between the Aid flow (current US$) of Bahamas and Aid flow (current US$) of Bangladesh?
Your response must be concise. -4.96e+07. In the year 1978, what is the difference between the Aid flow (current US$) in Bahamas and Aid flow (current US$) in Cabo Verde?
Give a very brief answer. -2.91e+06. In the year 1978, what is the difference between the Aid flow (current US$) of Bahamas and Aid flow (current US$) of Samoa?
Your answer should be compact. -8.00e+05. In the year 1978, what is the difference between the Aid flow (current US$) of Bangladesh and Aid flow (current US$) of Cabo Verde?
Give a very brief answer. 4.67e+07. In the year 1978, what is the difference between the Aid flow (current US$) in Bangladesh and Aid flow (current US$) in Samoa?
Give a very brief answer. 4.88e+07. In the year 1978, what is the difference between the Aid flow (current US$) in Cabo Verde and Aid flow (current US$) in Samoa?
Provide a short and direct response. 2.11e+06. In the year 1979, what is the difference between the Aid flow (current US$) in Bahamas and Aid flow (current US$) in Bangladesh?
Keep it short and to the point. -8.65e+07. In the year 1979, what is the difference between the Aid flow (current US$) of Bahamas and Aid flow (current US$) of Cabo Verde?
Keep it short and to the point. -5.87e+06. In the year 1979, what is the difference between the Aid flow (current US$) in Bahamas and Aid flow (current US$) in Samoa?
Offer a very short reply. -7.41e+06. In the year 1979, what is the difference between the Aid flow (current US$) of Bangladesh and Aid flow (current US$) of Cabo Verde?
Your response must be concise. 8.07e+07. In the year 1979, what is the difference between the Aid flow (current US$) of Bangladesh and Aid flow (current US$) of Samoa?
Give a very brief answer. 7.91e+07. In the year 1979, what is the difference between the Aid flow (current US$) of Cabo Verde and Aid flow (current US$) of Samoa?
Offer a very short reply. -1.54e+06. In the year 1980, what is the difference between the Aid flow (current US$) of Bahamas and Aid flow (current US$) of Bangladesh?
Make the answer very short. -1.15e+08. In the year 1980, what is the difference between the Aid flow (current US$) in Bahamas and Aid flow (current US$) in Cabo Verde?
Make the answer very short. -4.90e+06. In the year 1980, what is the difference between the Aid flow (current US$) of Bahamas and Aid flow (current US$) of Samoa?
Keep it short and to the point. -2.49e+06. In the year 1980, what is the difference between the Aid flow (current US$) of Bangladesh and Aid flow (current US$) of Cabo Verde?
Offer a terse response. 1.10e+08. In the year 1980, what is the difference between the Aid flow (current US$) of Bangladesh and Aid flow (current US$) of Samoa?
Provide a short and direct response. 1.12e+08. In the year 1980, what is the difference between the Aid flow (current US$) in Cabo Verde and Aid flow (current US$) in Samoa?
Provide a short and direct response. 2.41e+06. In the year 1981, what is the difference between the Aid flow (current US$) of Bahamas and Aid flow (current US$) of Bangladesh?
Offer a terse response. -1.01e+08. In the year 1981, what is the difference between the Aid flow (current US$) in Bahamas and Aid flow (current US$) in Cabo Verde?
Give a very brief answer. -3.83e+06. In the year 1981, what is the difference between the Aid flow (current US$) in Bahamas and Aid flow (current US$) in Samoa?
Your answer should be compact. -1.69e+06. In the year 1981, what is the difference between the Aid flow (current US$) of Bangladesh and Aid flow (current US$) of Cabo Verde?
Ensure brevity in your answer.  9.73e+07. In the year 1981, what is the difference between the Aid flow (current US$) of Bangladesh and Aid flow (current US$) of Samoa?
Give a very brief answer. 9.95e+07. In the year 1981, what is the difference between the Aid flow (current US$) in Cabo Verde and Aid flow (current US$) in Samoa?
Give a very brief answer. 2.14e+06. In the year 1982, what is the difference between the Aid flow (current US$) in Bahamas and Aid flow (current US$) in Bangladesh?
Make the answer very short. -8.27e+07. In the year 1982, what is the difference between the Aid flow (current US$) of Bahamas and Aid flow (current US$) of Cabo Verde?
Ensure brevity in your answer.  -8.86e+06. In the year 1982, what is the difference between the Aid flow (current US$) in Bahamas and Aid flow (current US$) in Samoa?
Keep it short and to the point. -1.23e+06. In the year 1982, what is the difference between the Aid flow (current US$) in Bangladesh and Aid flow (current US$) in Cabo Verde?
Give a very brief answer. 7.38e+07. In the year 1982, what is the difference between the Aid flow (current US$) of Bangladesh and Aid flow (current US$) of Samoa?
Your answer should be compact. 8.15e+07. In the year 1982, what is the difference between the Aid flow (current US$) in Cabo Verde and Aid flow (current US$) in Samoa?
Provide a short and direct response. 7.63e+06. In the year 1987, what is the difference between the Aid flow (current US$) in Bahamas and Aid flow (current US$) in Bangladesh?
Offer a terse response. -6.61e+07. In the year 1987, what is the difference between the Aid flow (current US$) of Bahamas and Aid flow (current US$) of Cabo Verde?
Your answer should be very brief. -1.32e+07. In the year 1987, what is the difference between the Aid flow (current US$) in Bahamas and Aid flow (current US$) in Samoa?
Offer a very short reply. -2.68e+06. In the year 1987, what is the difference between the Aid flow (current US$) of Bangladesh and Aid flow (current US$) of Cabo Verde?
Keep it short and to the point. 5.29e+07. In the year 1987, what is the difference between the Aid flow (current US$) of Bangladesh and Aid flow (current US$) of Samoa?
Give a very brief answer. 6.34e+07. In the year 1987, what is the difference between the Aid flow (current US$) in Cabo Verde and Aid flow (current US$) in Samoa?
Offer a terse response. 1.05e+07. In the year 1993, what is the difference between the Aid flow (current US$) of Bahamas and Aid flow (current US$) of Bangladesh?
Offer a very short reply. -7.52e+07. In the year 1993, what is the difference between the Aid flow (current US$) of Bahamas and Aid flow (current US$) of Cabo Verde?
Provide a short and direct response. -7.18e+06. In the year 1993, what is the difference between the Aid flow (current US$) of Bahamas and Aid flow (current US$) of Samoa?
Your response must be concise. -5.90e+05. In the year 1993, what is the difference between the Aid flow (current US$) of Bangladesh and Aid flow (current US$) of Cabo Verde?
Keep it short and to the point. 6.80e+07. In the year 1993, what is the difference between the Aid flow (current US$) of Bangladesh and Aid flow (current US$) of Samoa?
Offer a very short reply. 7.46e+07. In the year 1993, what is the difference between the Aid flow (current US$) in Cabo Verde and Aid flow (current US$) in Samoa?
Make the answer very short. 6.59e+06. What is the ratio of the Aid flow (current US$) of Bahamas in 1977 to that in 1978?
Ensure brevity in your answer.  2. What is the ratio of the Aid flow (current US$) in Bangladesh in 1977 to that in 1978?
Provide a succinct answer. 1.05. What is the ratio of the Aid flow (current US$) of Cabo Verde in 1977 to that in 1978?
Keep it short and to the point. 0.71. What is the ratio of the Aid flow (current US$) of Samoa in 1977 to that in 1978?
Offer a terse response. 0.28. What is the ratio of the Aid flow (current US$) of Bahamas in 1977 to that in 1979?
Your answer should be very brief. 1. What is the ratio of the Aid flow (current US$) in Bangladesh in 1977 to that in 1979?
Ensure brevity in your answer.  0.6. What is the ratio of the Aid flow (current US$) in Cabo Verde in 1977 to that in 1979?
Offer a very short reply. 0.35. What is the ratio of the Aid flow (current US$) in Samoa in 1977 to that in 1979?
Your answer should be compact. 0.03. What is the ratio of the Aid flow (current US$) of Bahamas in 1977 to that in 1980?
Make the answer very short. 1. What is the ratio of the Aid flow (current US$) in Bangladesh in 1977 to that in 1980?
Make the answer very short. 0.45. What is the ratio of the Aid flow (current US$) of Cabo Verde in 1977 to that in 1980?
Offer a very short reply. 0.42. What is the ratio of the Aid flow (current US$) in Samoa in 1977 to that in 1980?
Provide a succinct answer. 0.09. What is the ratio of the Aid flow (current US$) of Bangladesh in 1977 to that in 1981?
Your response must be concise. 0.51. What is the ratio of the Aid flow (current US$) in Cabo Verde in 1977 to that in 1981?
Ensure brevity in your answer.  0.54. What is the ratio of the Aid flow (current US$) in Samoa in 1977 to that in 1981?
Provide a short and direct response. 0.14. What is the ratio of the Aid flow (current US$) in Bahamas in 1977 to that in 1982?
Your answer should be compact. 2. What is the ratio of the Aid flow (current US$) in Bangladesh in 1977 to that in 1982?
Ensure brevity in your answer.  0.63. What is the ratio of the Aid flow (current US$) of Cabo Verde in 1977 to that in 1982?
Your answer should be very brief. 0.23. What is the ratio of the Aid flow (current US$) of Samoa in 1977 to that in 1982?
Offer a terse response. 0.19. What is the ratio of the Aid flow (current US$) in Bahamas in 1977 to that in 1987?
Provide a succinct answer. 2. What is the ratio of the Aid flow (current US$) of Bangladesh in 1977 to that in 1987?
Your answer should be very brief. 0.78. What is the ratio of the Aid flow (current US$) in Cabo Verde in 1977 to that in 1987?
Provide a short and direct response. 0.16. What is the ratio of the Aid flow (current US$) in Samoa in 1977 to that in 1987?
Make the answer very short. 0.09. What is the ratio of the Aid flow (current US$) in Bangladesh in 1977 to that in 1993?
Ensure brevity in your answer.  0.69. What is the ratio of the Aid flow (current US$) in Cabo Verde in 1977 to that in 1993?
Offer a very short reply. 0.29. What is the ratio of the Aid flow (current US$) of Samoa in 1977 to that in 1993?
Provide a short and direct response. 0.38. What is the ratio of the Aid flow (current US$) of Bangladesh in 1978 to that in 1979?
Provide a succinct answer. 0.57. What is the ratio of the Aid flow (current US$) in Cabo Verde in 1978 to that in 1979?
Keep it short and to the point. 0.5. What is the ratio of the Aid flow (current US$) of Samoa in 1978 to that in 1979?
Your answer should be compact. 0.11. What is the ratio of the Aid flow (current US$) in Bahamas in 1978 to that in 1980?
Offer a terse response. 0.5. What is the ratio of the Aid flow (current US$) in Bangladesh in 1978 to that in 1980?
Give a very brief answer. 0.43. What is the ratio of the Aid flow (current US$) of Cabo Verde in 1978 to that in 1980?
Make the answer very short. 0.59. What is the ratio of the Aid flow (current US$) in Samoa in 1978 to that in 1980?
Offer a terse response. 0.32. What is the ratio of the Aid flow (current US$) in Bahamas in 1978 to that in 1981?
Keep it short and to the point. 1. What is the ratio of the Aid flow (current US$) in Bangladesh in 1978 to that in 1981?
Provide a succinct answer. 0.49. What is the ratio of the Aid flow (current US$) of Cabo Verde in 1978 to that in 1981?
Ensure brevity in your answer.  0.76. What is the ratio of the Aid flow (current US$) in Samoa in 1978 to that in 1981?
Offer a very short reply. 0.48. What is the ratio of the Aid flow (current US$) in Bangladesh in 1978 to that in 1982?
Provide a short and direct response. 0.6. What is the ratio of the Aid flow (current US$) of Cabo Verde in 1978 to that in 1982?
Offer a terse response. 0.33. What is the ratio of the Aid flow (current US$) in Samoa in 1978 to that in 1982?
Make the answer very short. 0.65. What is the ratio of the Aid flow (current US$) in Bangladesh in 1978 to that in 1987?
Give a very brief answer. 0.75. What is the ratio of the Aid flow (current US$) of Cabo Verde in 1978 to that in 1987?
Your response must be concise. 0.22. What is the ratio of the Aid flow (current US$) of Samoa in 1978 to that in 1987?
Offer a very short reply. 0.3. What is the ratio of the Aid flow (current US$) of Bahamas in 1978 to that in 1993?
Your answer should be very brief. 1. What is the ratio of the Aid flow (current US$) of Bangladesh in 1978 to that in 1993?
Offer a terse response. 0.66. What is the ratio of the Aid flow (current US$) of Cabo Verde in 1978 to that in 1993?
Your answer should be very brief. 0.41. What is the ratio of the Aid flow (current US$) in Samoa in 1978 to that in 1993?
Offer a terse response. 1.35. What is the ratio of the Aid flow (current US$) in Bangladesh in 1979 to that in 1980?
Your answer should be very brief. 0.76. What is the ratio of the Aid flow (current US$) of Cabo Verde in 1979 to that in 1980?
Give a very brief answer. 1.2. What is the ratio of the Aid flow (current US$) in Samoa in 1979 to that in 1980?
Your answer should be very brief. 2.96. What is the ratio of the Aid flow (current US$) of Bangladesh in 1979 to that in 1981?
Your answer should be very brief. 0.86. What is the ratio of the Aid flow (current US$) of Cabo Verde in 1979 to that in 1981?
Offer a terse response. 1.53. What is the ratio of the Aid flow (current US$) of Samoa in 1979 to that in 1981?
Make the answer very short. 4.37. What is the ratio of the Aid flow (current US$) in Bangladesh in 1979 to that in 1982?
Provide a short and direct response. 1.05. What is the ratio of the Aid flow (current US$) in Cabo Verde in 1979 to that in 1982?
Ensure brevity in your answer.  0.66. What is the ratio of the Aid flow (current US$) of Samoa in 1979 to that in 1982?
Offer a very short reply. 5.99. What is the ratio of the Aid flow (current US$) in Bahamas in 1979 to that in 1987?
Offer a terse response. 2. What is the ratio of the Aid flow (current US$) in Bangladesh in 1979 to that in 1987?
Provide a succinct answer. 1.31. What is the ratio of the Aid flow (current US$) in Cabo Verde in 1979 to that in 1987?
Your response must be concise. 0.45. What is the ratio of the Aid flow (current US$) in Samoa in 1979 to that in 1987?
Your response must be concise. 2.76. What is the ratio of the Aid flow (current US$) in Bangladesh in 1979 to that in 1993?
Give a very brief answer. 1.15. What is the ratio of the Aid flow (current US$) in Cabo Verde in 1979 to that in 1993?
Offer a very short reply. 0.82. What is the ratio of the Aid flow (current US$) in Samoa in 1979 to that in 1993?
Make the answer very short. 12.38. What is the ratio of the Aid flow (current US$) of Bahamas in 1980 to that in 1981?
Offer a terse response. 2. What is the ratio of the Aid flow (current US$) of Bangladesh in 1980 to that in 1981?
Give a very brief answer. 1.13. What is the ratio of the Aid flow (current US$) in Cabo Verde in 1980 to that in 1981?
Give a very brief answer. 1.28. What is the ratio of the Aid flow (current US$) in Samoa in 1980 to that in 1981?
Provide a succinct answer. 1.48. What is the ratio of the Aid flow (current US$) in Bahamas in 1980 to that in 1982?
Your answer should be very brief. 2. What is the ratio of the Aid flow (current US$) of Bangladesh in 1980 to that in 1982?
Provide a short and direct response. 1.39. What is the ratio of the Aid flow (current US$) in Cabo Verde in 1980 to that in 1982?
Provide a succinct answer. 0.55. What is the ratio of the Aid flow (current US$) of Samoa in 1980 to that in 1982?
Your answer should be very brief. 2.02. What is the ratio of the Aid flow (current US$) of Bangladesh in 1980 to that in 1987?
Make the answer very short. 1.73. What is the ratio of the Aid flow (current US$) in Cabo Verde in 1980 to that in 1987?
Offer a very short reply. 0.37. What is the ratio of the Aid flow (current US$) in Samoa in 1980 to that in 1987?
Keep it short and to the point. 0.93. What is the ratio of the Aid flow (current US$) in Bahamas in 1980 to that in 1993?
Provide a short and direct response. 2. What is the ratio of the Aid flow (current US$) of Bangladesh in 1980 to that in 1993?
Make the answer very short. 1.52. What is the ratio of the Aid flow (current US$) in Cabo Verde in 1980 to that in 1993?
Your response must be concise. 0.68. What is the ratio of the Aid flow (current US$) of Samoa in 1980 to that in 1993?
Your answer should be very brief. 4.18. What is the ratio of the Aid flow (current US$) in Bahamas in 1981 to that in 1982?
Make the answer very short. 1. What is the ratio of the Aid flow (current US$) of Bangladesh in 1981 to that in 1982?
Your answer should be compact. 1.22. What is the ratio of the Aid flow (current US$) of Cabo Verde in 1981 to that in 1982?
Your answer should be compact. 0.43. What is the ratio of the Aid flow (current US$) in Samoa in 1981 to that in 1982?
Provide a succinct answer. 1.37. What is the ratio of the Aid flow (current US$) of Bahamas in 1981 to that in 1987?
Keep it short and to the point. 1. What is the ratio of the Aid flow (current US$) of Bangladesh in 1981 to that in 1987?
Ensure brevity in your answer.  1.53. What is the ratio of the Aid flow (current US$) in Cabo Verde in 1981 to that in 1987?
Make the answer very short. 0.29. What is the ratio of the Aid flow (current US$) of Samoa in 1981 to that in 1987?
Make the answer very short. 0.63. What is the ratio of the Aid flow (current US$) in Bangladesh in 1981 to that in 1993?
Keep it short and to the point. 1.34. What is the ratio of the Aid flow (current US$) of Cabo Verde in 1981 to that in 1993?
Offer a terse response. 0.53. What is the ratio of the Aid flow (current US$) of Samoa in 1981 to that in 1993?
Provide a short and direct response. 2.83. What is the ratio of the Aid flow (current US$) of Bangladesh in 1982 to that in 1987?
Offer a terse response. 1.25. What is the ratio of the Aid flow (current US$) in Cabo Verde in 1982 to that in 1987?
Your answer should be compact. 0.67. What is the ratio of the Aid flow (current US$) in Samoa in 1982 to that in 1987?
Ensure brevity in your answer.  0.46. What is the ratio of the Aid flow (current US$) of Bahamas in 1982 to that in 1993?
Your answer should be very brief. 1. What is the ratio of the Aid flow (current US$) of Bangladesh in 1982 to that in 1993?
Provide a short and direct response. 1.1. What is the ratio of the Aid flow (current US$) in Cabo Verde in 1982 to that in 1993?
Offer a very short reply. 1.23. What is the ratio of the Aid flow (current US$) of Samoa in 1982 to that in 1993?
Your answer should be very brief. 2.07. What is the ratio of the Aid flow (current US$) of Bahamas in 1987 to that in 1993?
Keep it short and to the point. 1. What is the ratio of the Aid flow (current US$) of Bangladesh in 1987 to that in 1993?
Provide a succinct answer. 0.88. What is the ratio of the Aid flow (current US$) in Cabo Verde in 1987 to that in 1993?
Your answer should be compact. 1.84. What is the ratio of the Aid flow (current US$) of Samoa in 1987 to that in 1993?
Your response must be concise. 4.48. What is the difference between the highest and the second highest Aid flow (current US$) of Bahamas?
Your answer should be compact. 0. What is the difference between the highest and the second highest Aid flow (current US$) of Bangladesh?
Keep it short and to the point. 1.34e+07. What is the difference between the highest and the second highest Aid flow (current US$) in Cabo Verde?
Give a very brief answer. 4.33e+06. What is the difference between the highest and the second highest Aid flow (current US$) of Samoa?
Keep it short and to the point. 4.74e+06. What is the difference between the highest and the lowest Aid flow (current US$) in Bangladesh?
Make the answer very short. 6.50e+07. What is the difference between the highest and the lowest Aid flow (current US$) of Cabo Verde?
Offer a very short reply. 1.11e+07. What is the difference between the highest and the lowest Aid flow (current US$) of Samoa?
Offer a terse response. 7.20e+06. 